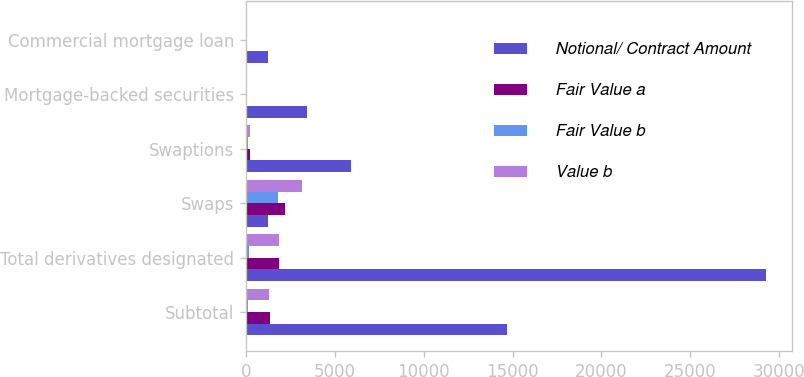Convert chart. <chart><loc_0><loc_0><loc_500><loc_500><stacked_bar_chart><ecel><fcel>Subtotal<fcel>Total derivatives designated<fcel>Swaps<fcel>Swaptions<fcel>Mortgage-backed securities<fcel>Commercial mortgage loan<nl><fcel>Notional/ Contract Amount<fcel>14713<fcel>29270<fcel>1259<fcel>5890<fcel>3429<fcel>1259<nl><fcel>Fair Value a<fcel>1367<fcel>1872<fcel>2204<fcel>209<fcel>3<fcel>12<nl><fcel>Fair Value b<fcel>144<fcel>152<fcel>1790<fcel>119<fcel>1<fcel>9<nl><fcel>Value b<fcel>1316<fcel>1888<fcel>3127<fcel>216<fcel>47<fcel>8<nl></chart> 